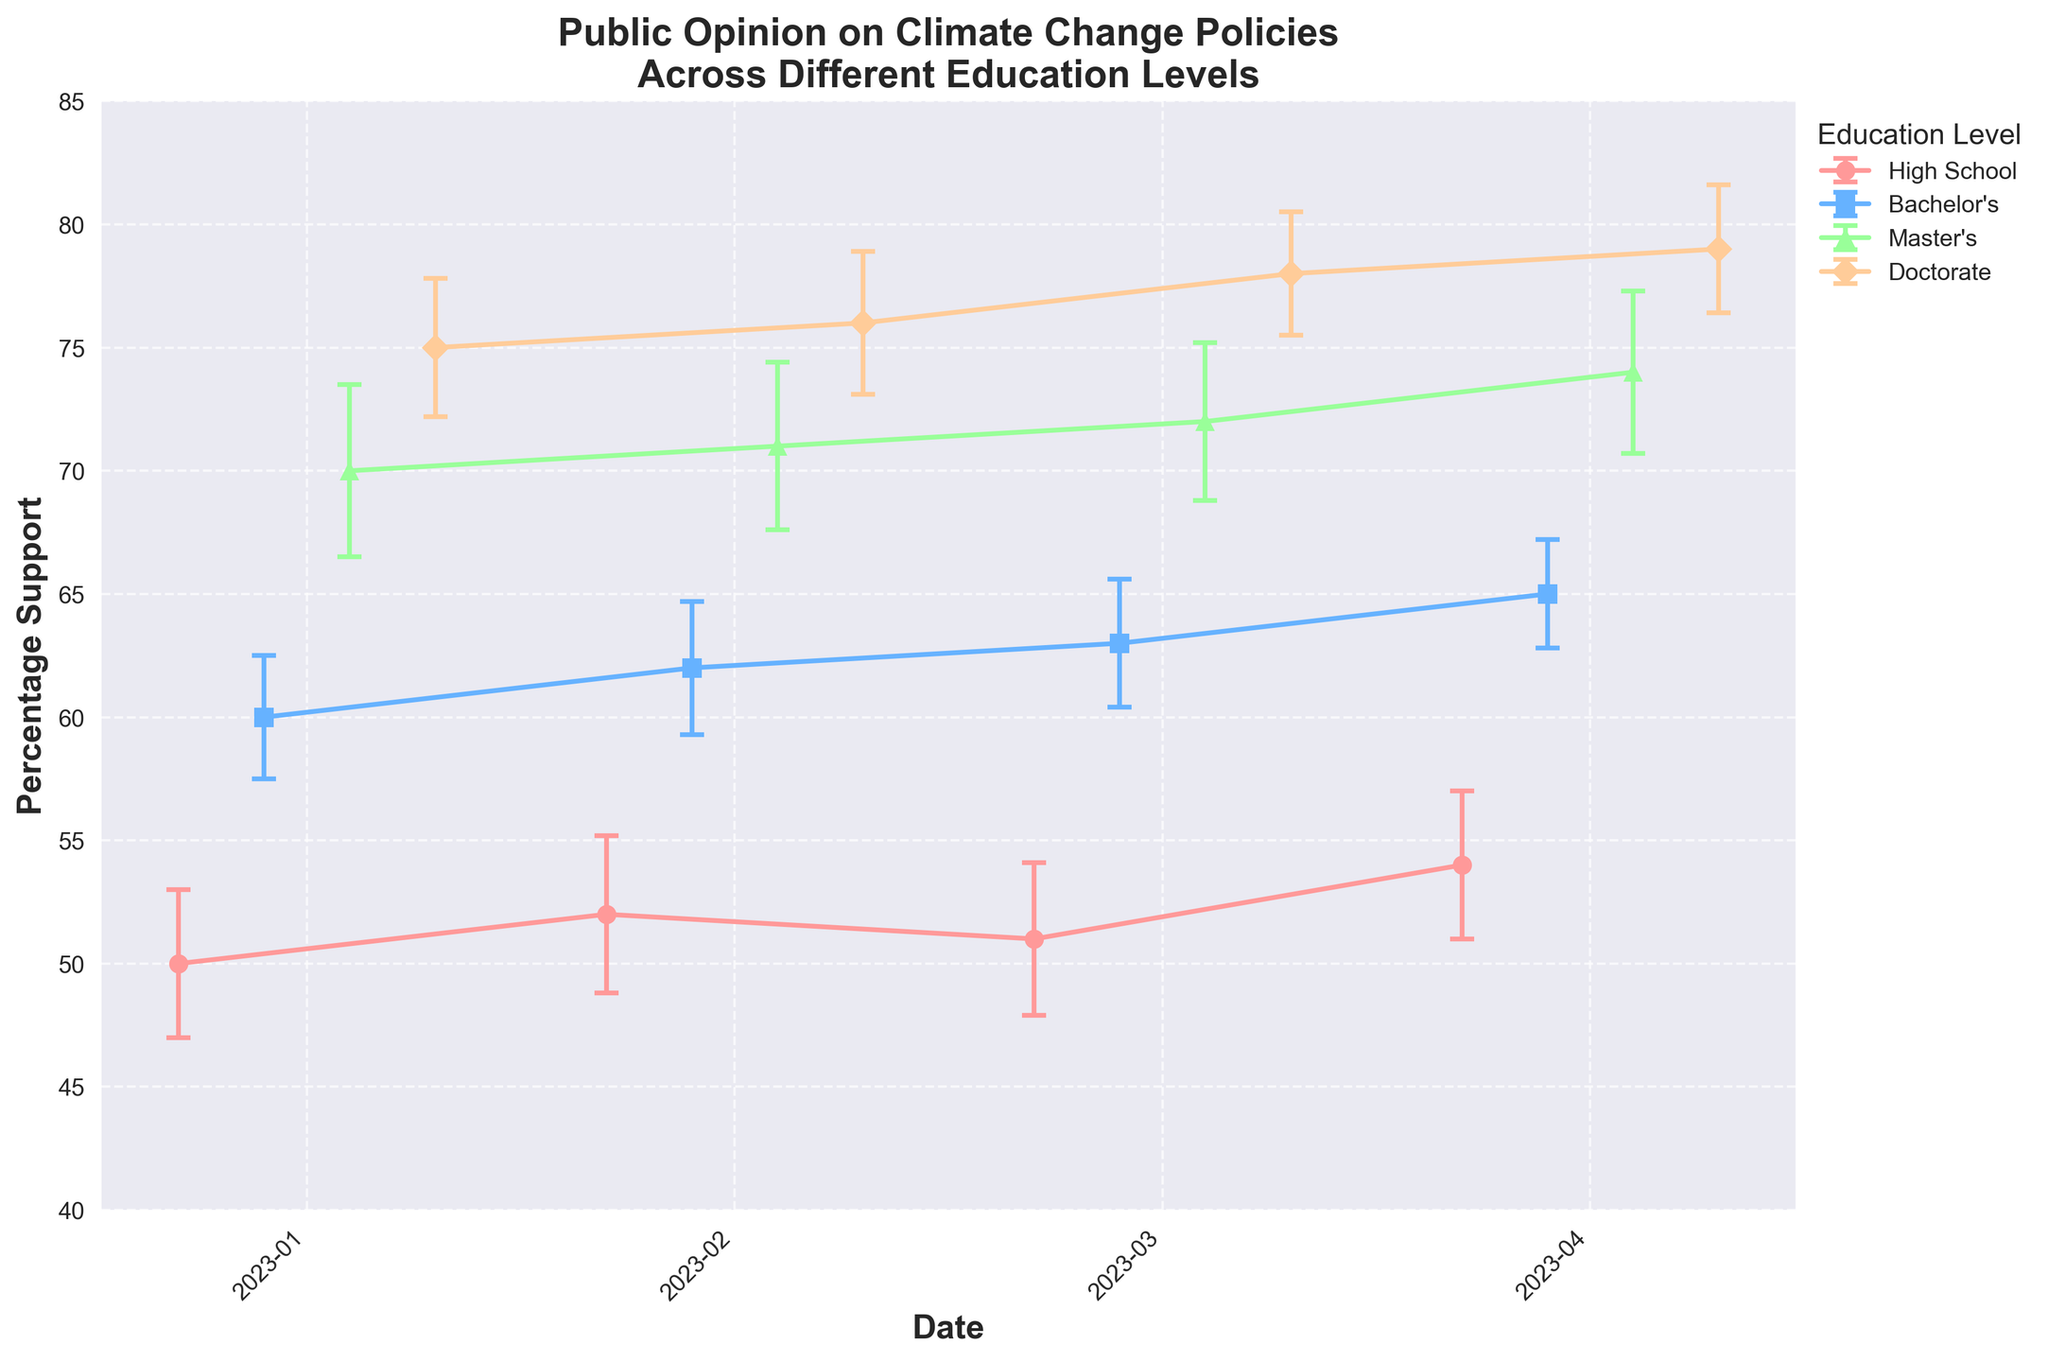What's the title of the figure? The figure's title is located at the top center of the plot. It reads "Public Opinion on Climate Change Policies Across Different Education Levels."
Answer: Public Opinion on Climate Change Policies Across Different Education Levels Which education level has the highest percentage of support in January 2023? From the error bars related to January 2023, the group with the highest percentage support is the Doctorate level, which is 75%.
Answer: Doctorate What is the range of percentage support for Master's education level across the months? To determine the range, identify the highest and lowest support percentages for Master's level. These are 74% in April and 70% in January, respectively. The range is 74% - 70% = 4%.
Answer: 4% How does the percentage support for climate change policies differ between High School and Doctorate education levels in April 2023? Locate the percentage supports for High School and Doctorate levels in April 2023. For High School, it's 54%, and for Doctorate, it's 79%. The difference is 79% - 54% = 25%.
Answer: 25% In which month did the Bachelor's education level show the maximum increase in percentage support? Compare the percentage support across epochs. Bachelor's level rises from 60% in January to 65% in April. The highest increase of 5% (65% - 60%) happens from February to April.
Answer: April What is the average percentage support for climate change policies for Master's education level from January to April 2023? Add the percentages for Master's level across all months (70% + 71% + 72% + 74%) and divide by the number of months (4). The calculation is (70 + 71 + 72 + 74) / 4 = 71.75%.
Answer: 71.75% Which education level demonstrates the least variation in percentage support over time? Check the variation (difference between the maximum and minimum support) for each level. High School varies by 4% (54%-50%), Bachelor's by 5% (65%-60%), Master's by 4% (74%-70%), and Doctorate by 4% (79%-75%). Both High School, Master's, and Doctorate levels have the smallest variation of 4%.
Answer: High School, Master's, Doctorate Is there a month where more than one education level has the same percentage support? Scan the figure to see if any overlapping data points exist for different education levels within the same month. There are no such cases within the January to April 2023 timeframe.
Answer: No How does the error margin for High School education level in March 2023 compare to that in January 2023? Identify error margins for High School level in March and January. They are 3.1% in March and 3% in January, respectively. The difference is 3.1% - 3% = 0.1%.
Answer: March's error margin is 0.1% higher than January's 